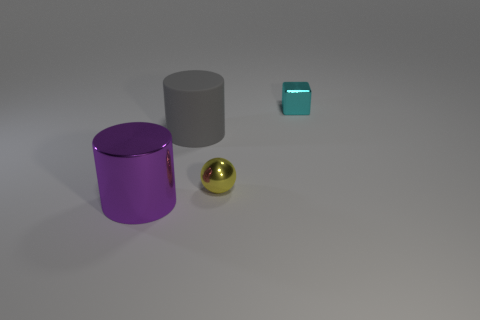What lighting conditions are present in the image, and how do they affect the appearance of the objects? The image seems to be lit by a soft, diffuse light source, likely situated above and possibly in front of the objects. This lighting casts gentle shadows directly under the objects, allowing their colors and shapes to be easily discernible without harsh reflections or deep contrasting shadows. The soft lighting assists in showcasing the objects' textures and material properties without distortion. 